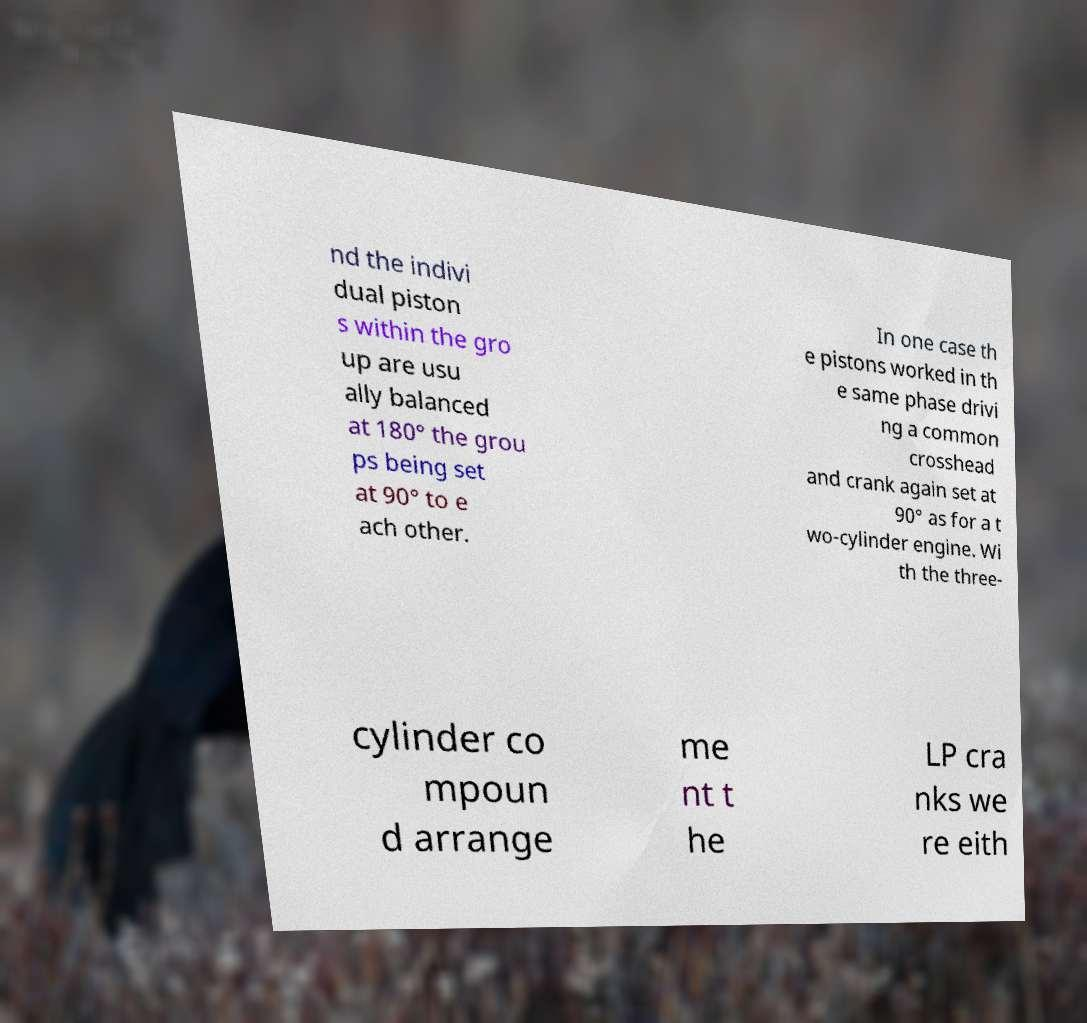Could you extract and type out the text from this image? nd the indivi dual piston s within the gro up are usu ally balanced at 180° the grou ps being set at 90° to e ach other. In one case th e pistons worked in th e same phase drivi ng a common crosshead and crank again set at 90° as for a t wo-cylinder engine. Wi th the three- cylinder co mpoun d arrange me nt t he LP cra nks we re eith 